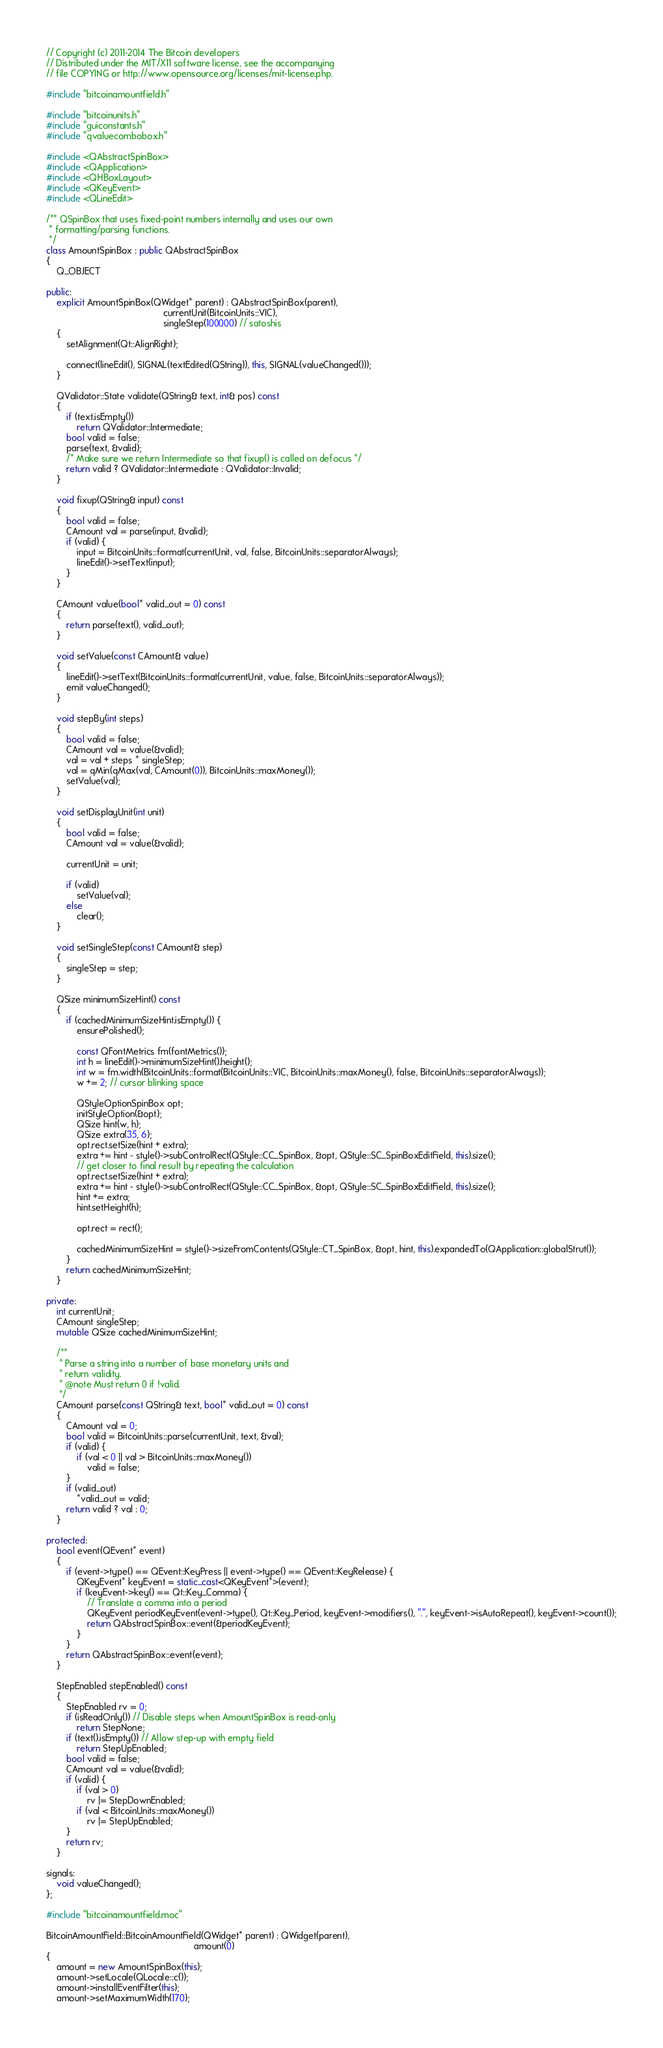Convert code to text. <code><loc_0><loc_0><loc_500><loc_500><_C++_>// Copyright (c) 2011-2014 The Bitcoin developers
// Distributed under the MIT/X11 software license, see the accompanying
// file COPYING or http://www.opensource.org/licenses/mit-license.php.

#include "bitcoinamountfield.h"

#include "bitcoinunits.h"
#include "guiconstants.h"
#include "qvaluecombobox.h"

#include <QAbstractSpinBox>
#include <QApplication>
#include <QHBoxLayout>
#include <QKeyEvent>
#include <QLineEdit>

/** QSpinBox that uses fixed-point numbers internally and uses our own
 * formatting/parsing functions.
 */
class AmountSpinBox : public QAbstractSpinBox
{
    Q_OBJECT

public:
    explicit AmountSpinBox(QWidget* parent) : QAbstractSpinBox(parent),
                                              currentUnit(BitcoinUnits::VIC),
                                              singleStep(100000) // satoshis
    {
        setAlignment(Qt::AlignRight);

        connect(lineEdit(), SIGNAL(textEdited(QString)), this, SIGNAL(valueChanged()));
    }

    QValidator::State validate(QString& text, int& pos) const
    {
        if (text.isEmpty())
            return QValidator::Intermediate;
        bool valid = false;
        parse(text, &valid);
        /* Make sure we return Intermediate so that fixup() is called on defocus */
        return valid ? QValidator::Intermediate : QValidator::Invalid;
    }

    void fixup(QString& input) const
    {
        bool valid = false;
        CAmount val = parse(input, &valid);
        if (valid) {
            input = BitcoinUnits::format(currentUnit, val, false, BitcoinUnits::separatorAlways);
            lineEdit()->setText(input);
        }
    }

    CAmount value(bool* valid_out = 0) const
    {
        return parse(text(), valid_out);
    }

    void setValue(const CAmount& value)
    {
        lineEdit()->setText(BitcoinUnits::format(currentUnit, value, false, BitcoinUnits::separatorAlways));
        emit valueChanged();
    }

    void stepBy(int steps)
    {
        bool valid = false;
        CAmount val = value(&valid);
        val = val + steps * singleStep;
        val = qMin(qMax(val, CAmount(0)), BitcoinUnits::maxMoney());
        setValue(val);
    }

    void setDisplayUnit(int unit)
    {
        bool valid = false;
        CAmount val = value(&valid);

        currentUnit = unit;

        if (valid)
            setValue(val);
        else
            clear();
    }

    void setSingleStep(const CAmount& step)
    {
        singleStep = step;
    }

    QSize minimumSizeHint() const
    {
        if (cachedMinimumSizeHint.isEmpty()) {
            ensurePolished();

            const QFontMetrics fm(fontMetrics());
            int h = lineEdit()->minimumSizeHint().height();
            int w = fm.width(BitcoinUnits::format(BitcoinUnits::VIC, BitcoinUnits::maxMoney(), false, BitcoinUnits::separatorAlways));
            w += 2; // cursor blinking space

            QStyleOptionSpinBox opt;
            initStyleOption(&opt);
            QSize hint(w, h);
            QSize extra(35, 6);
            opt.rect.setSize(hint + extra);
            extra += hint - style()->subControlRect(QStyle::CC_SpinBox, &opt, QStyle::SC_SpinBoxEditField, this).size();
            // get closer to final result by repeating the calculation
            opt.rect.setSize(hint + extra);
            extra += hint - style()->subControlRect(QStyle::CC_SpinBox, &opt, QStyle::SC_SpinBoxEditField, this).size();
            hint += extra;
            hint.setHeight(h);

            opt.rect = rect();

            cachedMinimumSizeHint = style()->sizeFromContents(QStyle::CT_SpinBox, &opt, hint, this).expandedTo(QApplication::globalStrut());
        }
        return cachedMinimumSizeHint;
    }

private:
    int currentUnit;
    CAmount singleStep;
    mutable QSize cachedMinimumSizeHint;

    /**
     * Parse a string into a number of base monetary units and
     * return validity.
     * @note Must return 0 if !valid.
     */
    CAmount parse(const QString& text, bool* valid_out = 0) const
    {
        CAmount val = 0;
        bool valid = BitcoinUnits::parse(currentUnit, text, &val);
        if (valid) {
            if (val < 0 || val > BitcoinUnits::maxMoney())
                valid = false;
        }
        if (valid_out)
            *valid_out = valid;
        return valid ? val : 0;
    }

protected:
    bool event(QEvent* event)
    {
        if (event->type() == QEvent::KeyPress || event->type() == QEvent::KeyRelease) {
            QKeyEvent* keyEvent = static_cast<QKeyEvent*>(event);
            if (keyEvent->key() == Qt::Key_Comma) {
                // Translate a comma into a period
                QKeyEvent periodKeyEvent(event->type(), Qt::Key_Period, keyEvent->modifiers(), ".", keyEvent->isAutoRepeat(), keyEvent->count());
                return QAbstractSpinBox::event(&periodKeyEvent);
            }
        }
        return QAbstractSpinBox::event(event);
    }

    StepEnabled stepEnabled() const
    {
        StepEnabled rv = 0;
        if (isReadOnly()) // Disable steps when AmountSpinBox is read-only
            return StepNone;
        if (text().isEmpty()) // Allow step-up with empty field
            return StepUpEnabled;
        bool valid = false;
        CAmount val = value(&valid);
        if (valid) {
            if (val > 0)
                rv |= StepDownEnabled;
            if (val < BitcoinUnits::maxMoney())
                rv |= StepUpEnabled;
        }
        return rv;
    }

signals:
    void valueChanged();
};

#include "bitcoinamountfield.moc"

BitcoinAmountField::BitcoinAmountField(QWidget* parent) : QWidget(parent),
                                                          amount(0)
{
    amount = new AmountSpinBox(this);
    amount->setLocale(QLocale::c());
    amount->installEventFilter(this);
    amount->setMaximumWidth(170);
</code> 